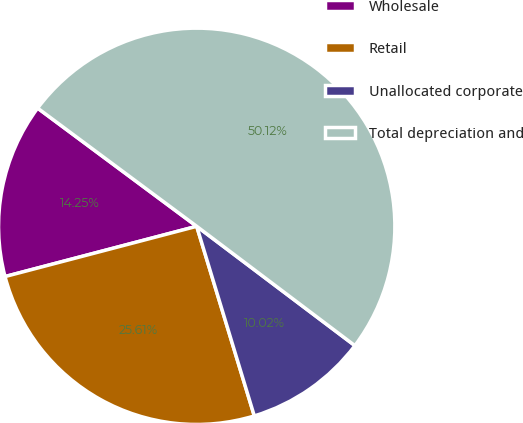<chart> <loc_0><loc_0><loc_500><loc_500><pie_chart><fcel>Wholesale<fcel>Retail<fcel>Unallocated corporate<fcel>Total depreciation and<nl><fcel>14.25%<fcel>25.61%<fcel>10.02%<fcel>50.11%<nl></chart> 